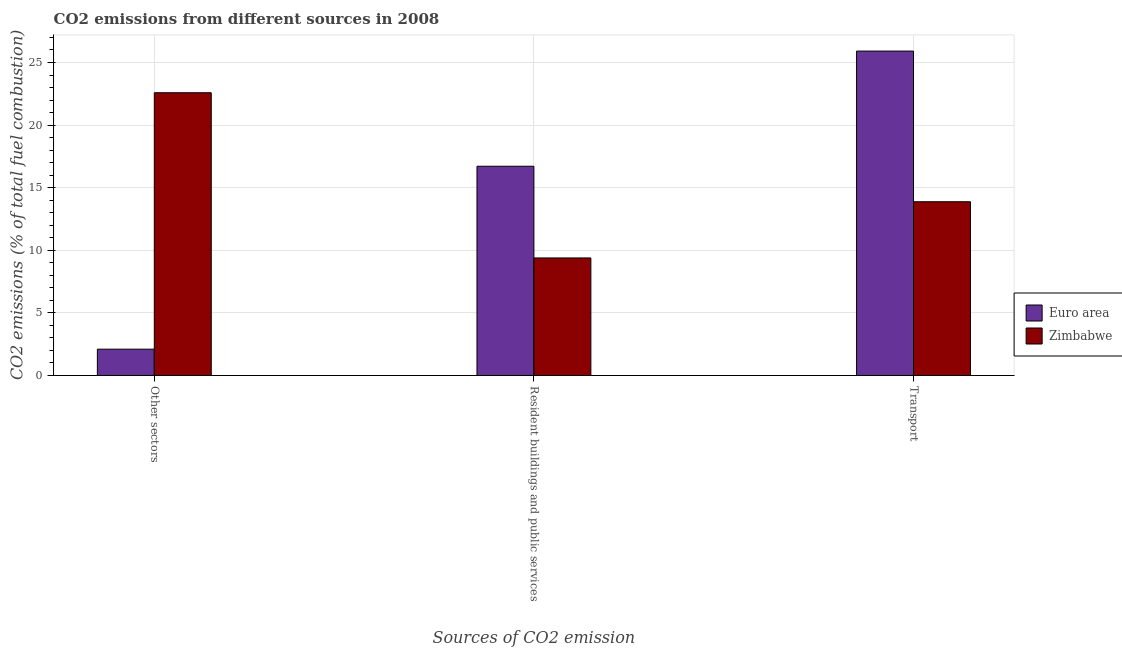How many different coloured bars are there?
Give a very brief answer. 2. How many groups of bars are there?
Make the answer very short. 3. Are the number of bars per tick equal to the number of legend labels?
Your response must be concise. Yes. Are the number of bars on each tick of the X-axis equal?
Your answer should be compact. Yes. How many bars are there on the 1st tick from the right?
Make the answer very short. 2. What is the label of the 1st group of bars from the left?
Your answer should be compact. Other sectors. What is the percentage of co2 emissions from resident buildings and public services in Euro area?
Make the answer very short. 16.71. Across all countries, what is the maximum percentage of co2 emissions from resident buildings and public services?
Offer a terse response. 16.71. Across all countries, what is the minimum percentage of co2 emissions from other sectors?
Provide a short and direct response. 2.1. In which country was the percentage of co2 emissions from transport maximum?
Make the answer very short. Euro area. In which country was the percentage of co2 emissions from resident buildings and public services minimum?
Offer a terse response. Zimbabwe. What is the total percentage of co2 emissions from other sectors in the graph?
Give a very brief answer. 24.69. What is the difference between the percentage of co2 emissions from transport in Euro area and that in Zimbabwe?
Provide a short and direct response. 12.03. What is the difference between the percentage of co2 emissions from transport in Euro area and the percentage of co2 emissions from resident buildings and public services in Zimbabwe?
Make the answer very short. 16.52. What is the average percentage of co2 emissions from other sectors per country?
Provide a succinct answer. 12.34. What is the difference between the percentage of co2 emissions from other sectors and percentage of co2 emissions from transport in Zimbabwe?
Offer a terse response. 8.71. What is the ratio of the percentage of co2 emissions from other sectors in Euro area to that in Zimbabwe?
Ensure brevity in your answer.  0.09. Is the percentage of co2 emissions from resident buildings and public services in Zimbabwe less than that in Euro area?
Provide a succinct answer. Yes. Is the difference between the percentage of co2 emissions from transport in Euro area and Zimbabwe greater than the difference between the percentage of co2 emissions from other sectors in Euro area and Zimbabwe?
Provide a succinct answer. Yes. What is the difference between the highest and the second highest percentage of co2 emissions from transport?
Ensure brevity in your answer.  12.03. What is the difference between the highest and the lowest percentage of co2 emissions from resident buildings and public services?
Offer a terse response. 7.33. What does the 2nd bar from the left in Transport represents?
Your answer should be compact. Zimbabwe. Is it the case that in every country, the sum of the percentage of co2 emissions from other sectors and percentage of co2 emissions from resident buildings and public services is greater than the percentage of co2 emissions from transport?
Offer a terse response. No. How many bars are there?
Make the answer very short. 6. Are all the bars in the graph horizontal?
Your response must be concise. No. What is the difference between two consecutive major ticks on the Y-axis?
Keep it short and to the point. 5. Does the graph contain grids?
Keep it short and to the point. Yes. Where does the legend appear in the graph?
Keep it short and to the point. Center right. How many legend labels are there?
Keep it short and to the point. 2. What is the title of the graph?
Give a very brief answer. CO2 emissions from different sources in 2008. What is the label or title of the X-axis?
Your answer should be compact. Sources of CO2 emission. What is the label or title of the Y-axis?
Provide a short and direct response. CO2 emissions (% of total fuel combustion). What is the CO2 emissions (% of total fuel combustion) in Euro area in Other sectors?
Your response must be concise. 2.1. What is the CO2 emissions (% of total fuel combustion) in Zimbabwe in Other sectors?
Your answer should be very brief. 22.59. What is the CO2 emissions (% of total fuel combustion) of Euro area in Resident buildings and public services?
Offer a very short reply. 16.71. What is the CO2 emissions (% of total fuel combustion) in Zimbabwe in Resident buildings and public services?
Your response must be concise. 9.39. What is the CO2 emissions (% of total fuel combustion) of Euro area in Transport?
Your response must be concise. 25.91. What is the CO2 emissions (% of total fuel combustion) in Zimbabwe in Transport?
Your answer should be compact. 13.88. Across all Sources of CO2 emission, what is the maximum CO2 emissions (% of total fuel combustion) of Euro area?
Ensure brevity in your answer.  25.91. Across all Sources of CO2 emission, what is the maximum CO2 emissions (% of total fuel combustion) of Zimbabwe?
Give a very brief answer. 22.59. Across all Sources of CO2 emission, what is the minimum CO2 emissions (% of total fuel combustion) in Euro area?
Provide a succinct answer. 2.1. Across all Sources of CO2 emission, what is the minimum CO2 emissions (% of total fuel combustion) of Zimbabwe?
Offer a very short reply. 9.39. What is the total CO2 emissions (% of total fuel combustion) in Euro area in the graph?
Your response must be concise. 44.73. What is the total CO2 emissions (% of total fuel combustion) of Zimbabwe in the graph?
Provide a short and direct response. 45.85. What is the difference between the CO2 emissions (% of total fuel combustion) of Euro area in Other sectors and that in Resident buildings and public services?
Make the answer very short. -14.61. What is the difference between the CO2 emissions (% of total fuel combustion) in Zimbabwe in Other sectors and that in Resident buildings and public services?
Give a very brief answer. 13.2. What is the difference between the CO2 emissions (% of total fuel combustion) in Euro area in Other sectors and that in Transport?
Your answer should be very brief. -23.81. What is the difference between the CO2 emissions (% of total fuel combustion) of Zimbabwe in Other sectors and that in Transport?
Your response must be concise. 8.71. What is the difference between the CO2 emissions (% of total fuel combustion) in Euro area in Resident buildings and public services and that in Transport?
Give a very brief answer. -9.2. What is the difference between the CO2 emissions (% of total fuel combustion) in Zimbabwe in Resident buildings and public services and that in Transport?
Make the answer very short. -4.49. What is the difference between the CO2 emissions (% of total fuel combustion) in Euro area in Other sectors and the CO2 emissions (% of total fuel combustion) in Zimbabwe in Resident buildings and public services?
Provide a short and direct response. -7.29. What is the difference between the CO2 emissions (% of total fuel combustion) in Euro area in Other sectors and the CO2 emissions (% of total fuel combustion) in Zimbabwe in Transport?
Your answer should be very brief. -11.78. What is the difference between the CO2 emissions (% of total fuel combustion) in Euro area in Resident buildings and public services and the CO2 emissions (% of total fuel combustion) in Zimbabwe in Transport?
Offer a very short reply. 2.84. What is the average CO2 emissions (% of total fuel combustion) in Euro area per Sources of CO2 emission?
Offer a very short reply. 14.91. What is the average CO2 emissions (% of total fuel combustion) of Zimbabwe per Sources of CO2 emission?
Make the answer very short. 15.28. What is the difference between the CO2 emissions (% of total fuel combustion) of Euro area and CO2 emissions (% of total fuel combustion) of Zimbabwe in Other sectors?
Offer a very short reply. -20.48. What is the difference between the CO2 emissions (% of total fuel combustion) in Euro area and CO2 emissions (% of total fuel combustion) in Zimbabwe in Resident buildings and public services?
Keep it short and to the point. 7.33. What is the difference between the CO2 emissions (% of total fuel combustion) in Euro area and CO2 emissions (% of total fuel combustion) in Zimbabwe in Transport?
Offer a very short reply. 12.03. What is the ratio of the CO2 emissions (% of total fuel combustion) in Euro area in Other sectors to that in Resident buildings and public services?
Make the answer very short. 0.13. What is the ratio of the CO2 emissions (% of total fuel combustion) in Zimbabwe in Other sectors to that in Resident buildings and public services?
Provide a succinct answer. 2.41. What is the ratio of the CO2 emissions (% of total fuel combustion) of Euro area in Other sectors to that in Transport?
Offer a very short reply. 0.08. What is the ratio of the CO2 emissions (% of total fuel combustion) of Zimbabwe in Other sectors to that in Transport?
Ensure brevity in your answer.  1.63. What is the ratio of the CO2 emissions (% of total fuel combustion) in Euro area in Resident buildings and public services to that in Transport?
Give a very brief answer. 0.65. What is the ratio of the CO2 emissions (% of total fuel combustion) in Zimbabwe in Resident buildings and public services to that in Transport?
Give a very brief answer. 0.68. What is the difference between the highest and the second highest CO2 emissions (% of total fuel combustion) of Euro area?
Your response must be concise. 9.2. What is the difference between the highest and the second highest CO2 emissions (% of total fuel combustion) of Zimbabwe?
Provide a short and direct response. 8.71. What is the difference between the highest and the lowest CO2 emissions (% of total fuel combustion) in Euro area?
Keep it short and to the point. 23.81. What is the difference between the highest and the lowest CO2 emissions (% of total fuel combustion) in Zimbabwe?
Your answer should be very brief. 13.2. 